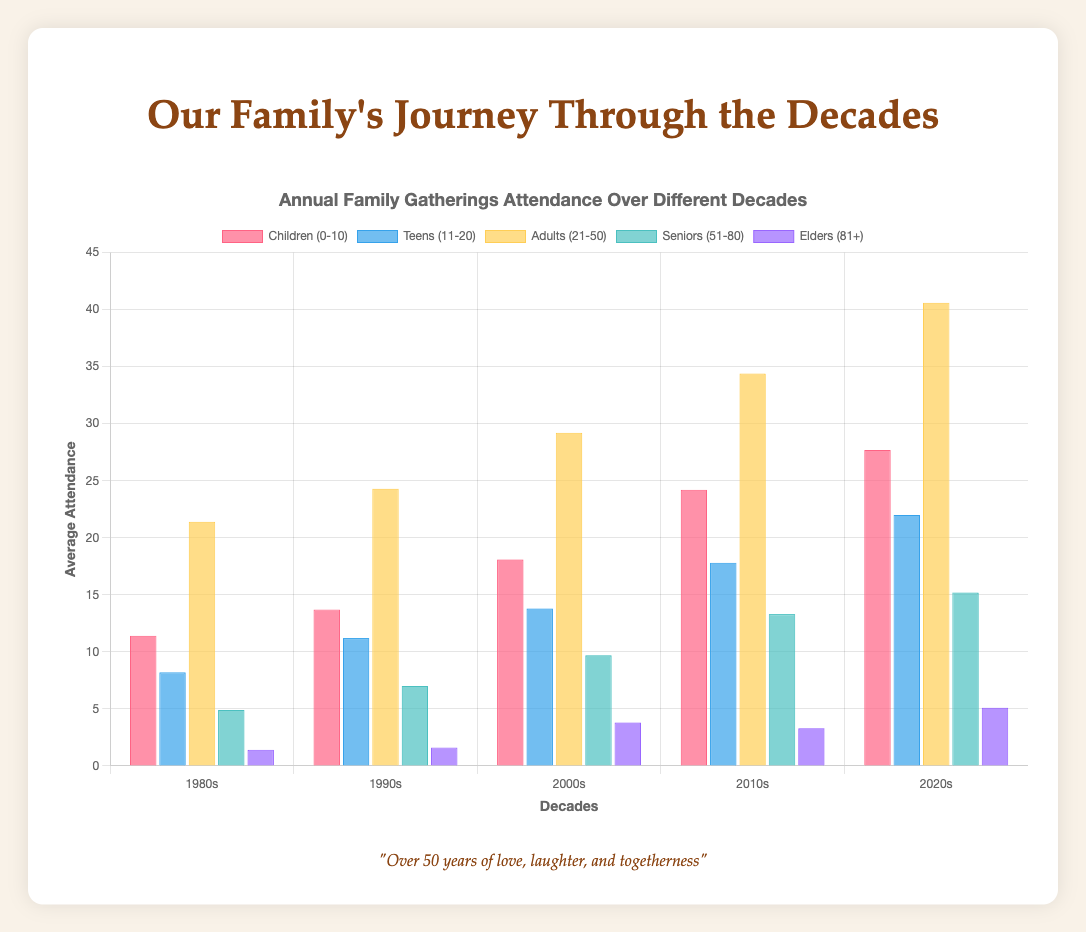How did the attendance of Children (0-10) change from the 1980s to the 2020s? The average attendance for Children (0-10) in the 1980s was 11.4 (sum of attendance divided by number of years). In the 2020s, it increased to 27.9. This shows a noticeable rise in attendance among children over the decades.
Answer: Increased Which decade saw the highest average attendance for Adults (21-50)? Calculate the average attendance of Adults (21-50) for each decade. The averages are:
1980s = 21.4, 1990s = 24.3, 2000s = 29.2, 2010s = 34.2, 2020s = 40.6. The highest average attendance for Adults (21-50) was in the 2020s.
Answer: 2020s Compare the average attendance of Seniors (51-80) and Elders (81+) in the 2000s. Which group had higher attendance? The average attendance for Seniors (51-80) in the 2000s was 9.7, while for Elders (81+) it was 3.8. Seniors had a higher average attendance compared to Elders in this decade.
Answer: Seniors (51-80) What is the trend in attendance for Teens (11-20) from the 1980s to the 2020s? Calculate the average attendance of Teens (11-20) across the decades. The averages are:
1980s = 8.2, 1990s = 11.2, 2000s = 13.7, 2010s = 17.8, 2020s = 22. Based on these values, there's a clear increasing trend in attendance for Teens from the 1980s to the 2020s.
Answer: Increasing How does the attendance of Elders (81+) in the 1980s compare visually to the attendance in the 2020s? Visually, the attendance for Elders (81+) in the 1980s (average = 1.3) is much lower than in the 2020s (average = 5). The height of the respective bars for these years reflects this significant increase.
Answer: 2020s has much higher What is the total sum of attendance for all age groups in the 2010s? Calculate the sum of average attendance for each age group in the 2010s: 
Children (0-10) = 23.6, Teens (11-20) = 17.8, Adults (21-50) = 34.2, Seniors (51-80) = 13.4, Elders (81+) = 3.3. Adding these together gives 92.3.
Answer: 92.3 In which decade did the Seniors (51-80) experience the highest increase in attendance compared to the previous decade? Calculate the difference in average attendance for Seniors (51-80) between each consecutive decade:
1990s-1980s = 2.2, 2000s-1990s = 1.2, 2010s-2000s = 3.8, 2020s-2010s = 2.6. The highest increase was from the 2000s to the 2010s.
Answer: 2010s What color represents the age group Children (0-10) in the chart? Visually, we see that the bars representing Children (0-10) are colored in a distinct shade of red.
Answer: Red 